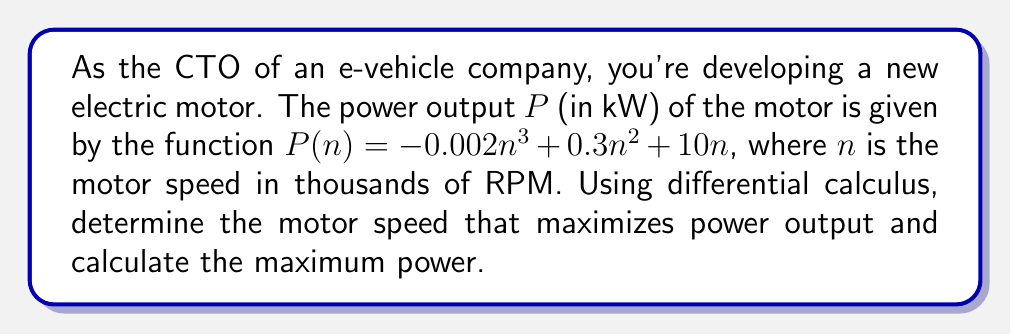Help me with this question. 1. To find the maximum power output, we need to find the critical points of the function $P(n)$ by setting its derivative equal to zero.

2. First, let's find the derivative of $P(n)$:
   $$P'(n) = -0.006n^2 + 0.6n + 10$$

3. Set $P'(n) = 0$ and solve for $n$:
   $$-0.006n^2 + 0.6n + 10 = 0$$

4. This is a quadratic equation. We can solve it using the quadratic formula:
   $$n = \frac{-b \pm \sqrt{b^2 - 4ac}}{2a}$$
   where $a = -0.006$, $b = 0.6$, and $c = 10$

5. Substituting these values:
   $$n = \frac{-0.6 \pm \sqrt{0.6^2 - 4(-0.006)(10)}}{2(-0.006)}$$
   $$= \frac{-0.6 \pm \sqrt{0.36 + 0.24}}{-0.012}$$
   $$= \frac{-0.6 \pm \sqrt{0.6}}{-0.012}$$
   $$= \frac{-0.6 \pm 0.7746}{-0.012}$$

6. This gives us two solutions:
   $$n_1 = \frac{-0.6 + 0.7746}{-0.012} \approx 14.55$$
   $$n_2 = \frac{-0.6 - 0.7746}{-0.012} \approx 114.55$$

7. To determine which solution gives the maximum, we can use the second derivative test:
   $$P''(n) = -0.012n + 0.6$$

8. Evaluating $P''(n)$ at $n_1 = 14.55$:
   $$P''(14.55) = -0.012(14.55) + 0.6 = 0.4254 > 0$$
   This indicates a local minimum at $n_1$.

9. Evaluating $P''(n)$ at $n_2 = 114.55$:
   $$P''(114.55) = -0.012(114.55) + 0.6 = -0.7746 < 0$$
   This indicates a local maximum at $n_2$.

10. Therefore, the maximum power output occurs at $n \approx 114.55$ thousand RPM.

11. To find the maximum power, we substitute this value back into the original function:
    $$P(114.55) = -0.002(114.55)^3 + 0.3(114.55)^2 + 10(114.55) \approx 7661.46$$

Thus, the maximum power output is approximately 7661.46 kW at 114,550 RPM.
Answer: Maximum power: 7661.46 kW at 114,550 RPM 